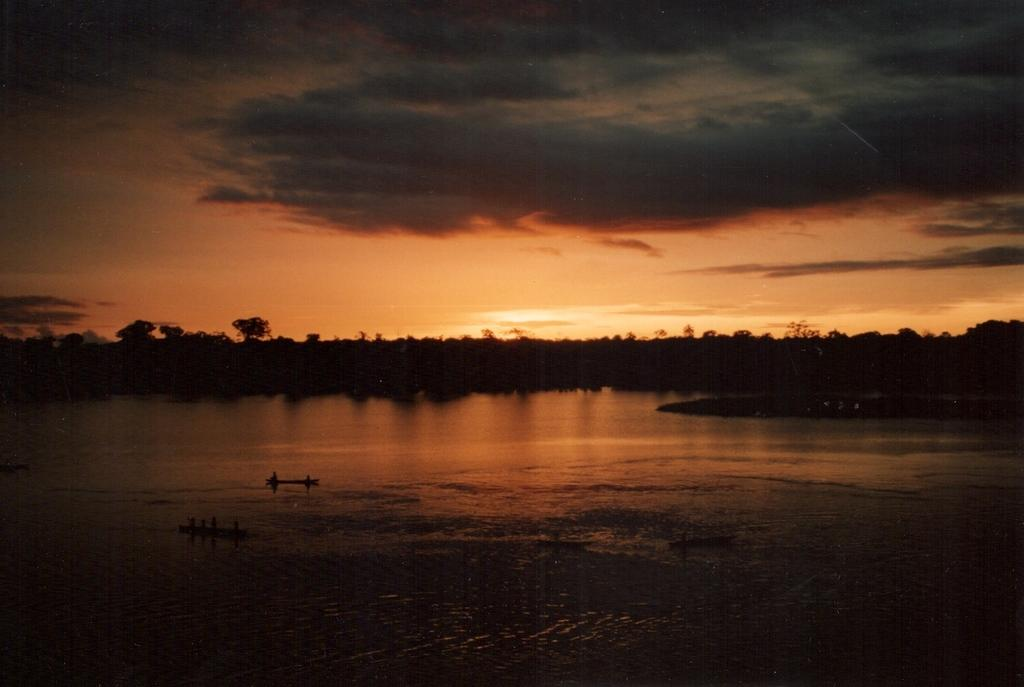What is the lighting condition in the image? The image was taken in the dark. What is located at the bottom of the image? There is a sea at the bottom of the image. What can be seen in the background of the image? There are many trees in the background of the image. What is visible at the top of the image? The sky is visible at the top of the image. What can be observed in the sky? Clouds are present in the sky. How many berries can be seen on the trees in the image? There are no berries visible in the image; only trees can be seen in the background. What type of sack is being used by the cows in the image? There are no cows present in the image, so it is not possible to determine if they are using any sacks. 